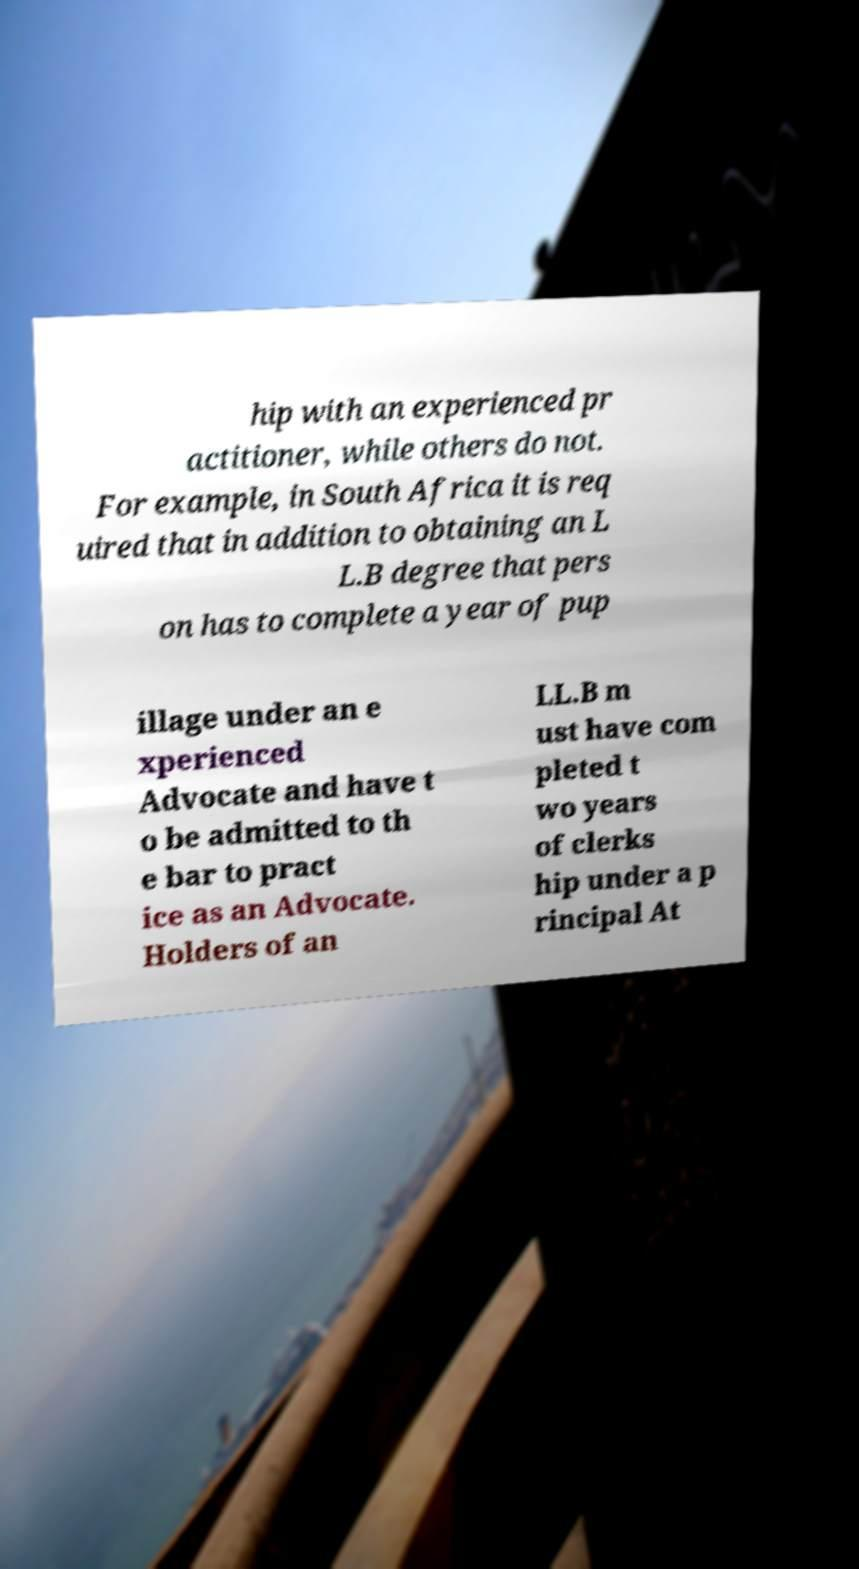Please read and relay the text visible in this image. What does it say? hip with an experienced pr actitioner, while others do not. For example, in South Africa it is req uired that in addition to obtaining an L L.B degree that pers on has to complete a year of pup illage under an e xperienced Advocate and have t o be admitted to th e bar to pract ice as an Advocate. Holders of an LL.B m ust have com pleted t wo years of clerks hip under a p rincipal At 